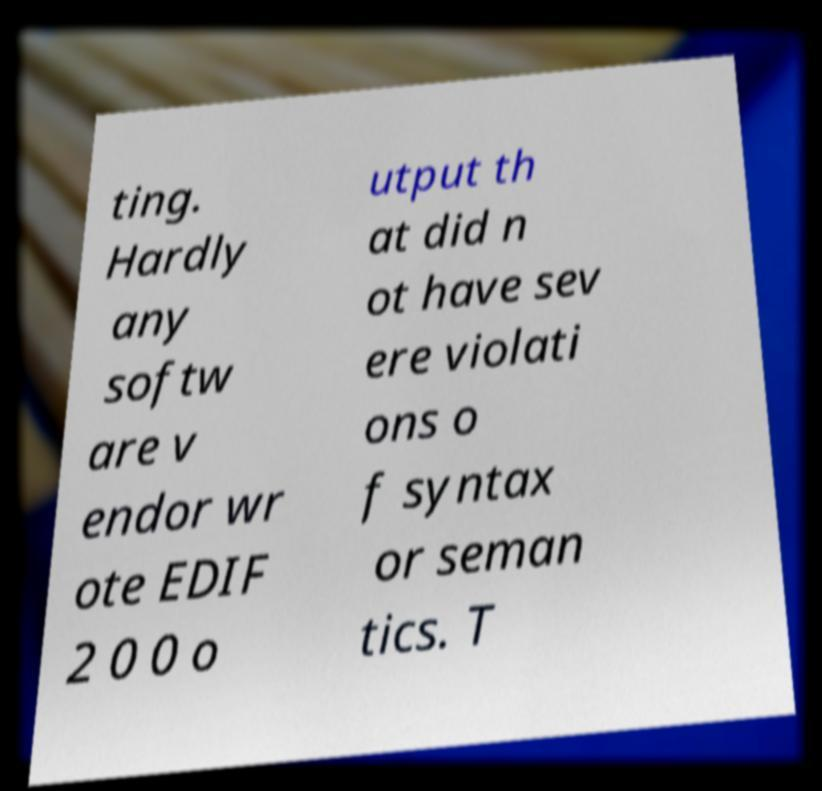Could you extract and type out the text from this image? ting. Hardly any softw are v endor wr ote EDIF 2 0 0 o utput th at did n ot have sev ere violati ons o f syntax or seman tics. T 